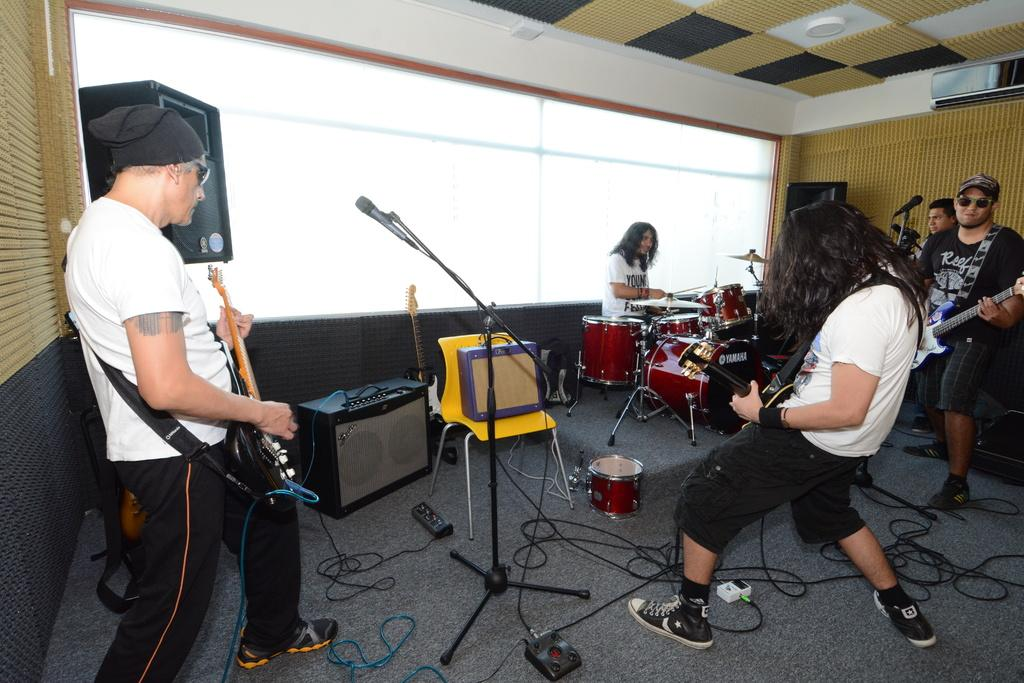How many people are in the room in the image? There is a group of people in the room. What are the people in the room doing? The people are playing musical instruments. What device might be used to amplify the sound of the instruments? There is a speaker in the room. What device might be used to capture the sound of the instruments or voices? There is a microphone in the room. What device might be used to regulate the temperature in the room? There is an air conditioner in the room. How much salt is on the table in the image? There is no table or salt present in the image. What type of battle is taking place in the image? There is no battle present in the image; it features a group of people playing musical instruments. 